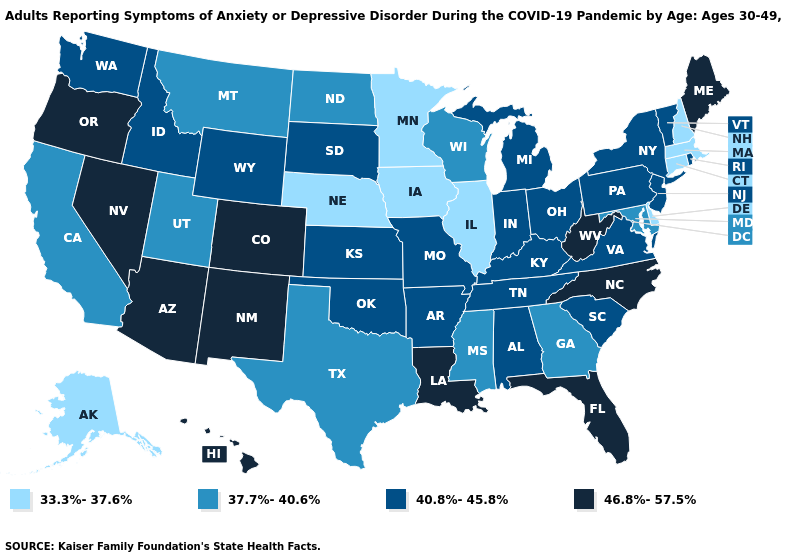Name the states that have a value in the range 37.7%-40.6%?
Write a very short answer. California, Georgia, Maryland, Mississippi, Montana, North Dakota, Texas, Utah, Wisconsin. What is the value of Arkansas?
Answer briefly. 40.8%-45.8%. What is the value of Colorado?
Give a very brief answer. 46.8%-57.5%. Does Georgia have the lowest value in the South?
Keep it brief. No. Does Massachusetts have the same value as Iowa?
Quick response, please. Yes. Does Kentucky have a lower value than New Mexico?
Keep it brief. Yes. Name the states that have a value in the range 37.7%-40.6%?
Be succinct. California, Georgia, Maryland, Mississippi, Montana, North Dakota, Texas, Utah, Wisconsin. Name the states that have a value in the range 33.3%-37.6%?
Short answer required. Alaska, Connecticut, Delaware, Illinois, Iowa, Massachusetts, Minnesota, Nebraska, New Hampshire. What is the value of Vermont?
Be succinct. 40.8%-45.8%. Which states hav the highest value in the MidWest?
Short answer required. Indiana, Kansas, Michigan, Missouri, Ohio, South Dakota. Does Florida have the highest value in the South?
Quick response, please. Yes. Name the states that have a value in the range 46.8%-57.5%?
Short answer required. Arizona, Colorado, Florida, Hawaii, Louisiana, Maine, Nevada, New Mexico, North Carolina, Oregon, West Virginia. Name the states that have a value in the range 37.7%-40.6%?
Be succinct. California, Georgia, Maryland, Mississippi, Montana, North Dakota, Texas, Utah, Wisconsin. What is the highest value in states that border Mississippi?
Be succinct. 46.8%-57.5%. 